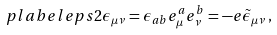Convert formula to latex. <formula><loc_0><loc_0><loc_500><loc_500>\ p l a b e l { e p s 2 } \epsilon _ { \mu \nu } = \epsilon _ { a b } e ^ { a } _ { \mu } e ^ { b } _ { \nu } = - e \tilde { \epsilon } _ { \mu \nu } \, ,</formula> 